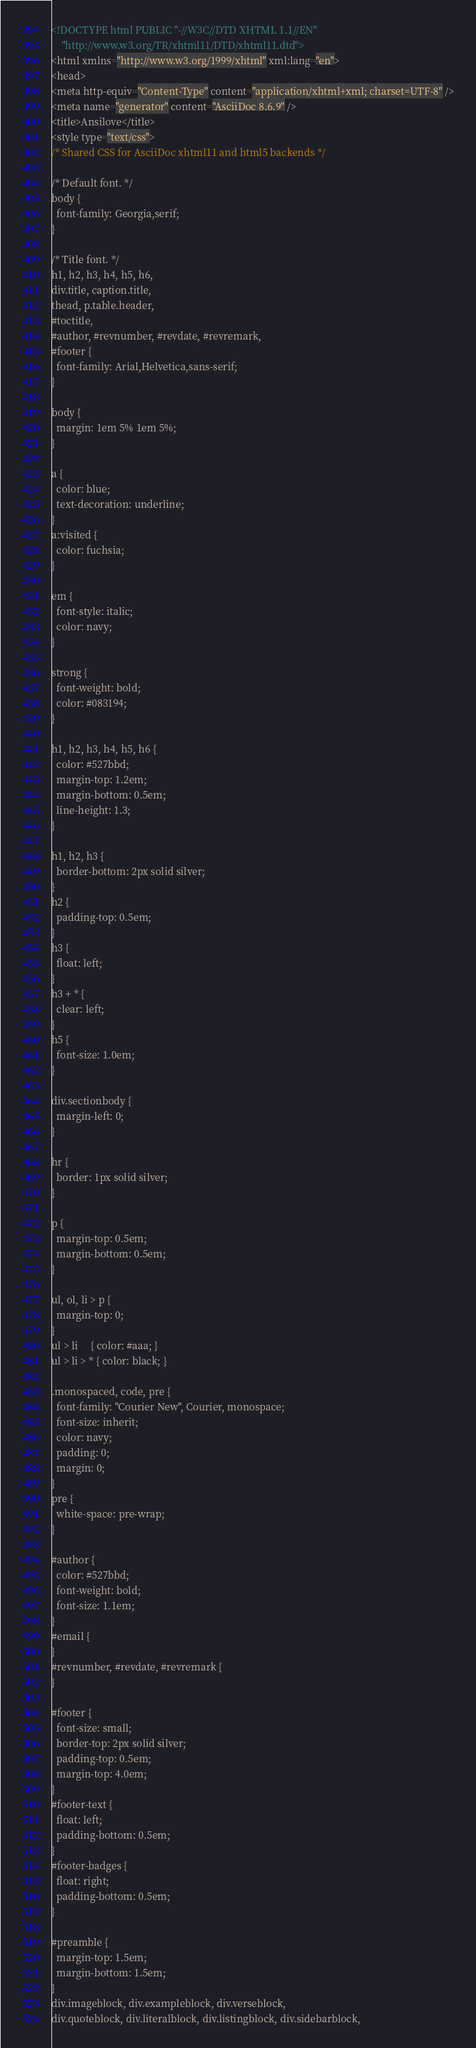<code> <loc_0><loc_0><loc_500><loc_500><_HTML_><!DOCTYPE html PUBLIC "-//W3C//DTD XHTML 1.1//EN"
    "http://www.w3.org/TR/xhtml11/DTD/xhtml11.dtd">
<html xmlns="http://www.w3.org/1999/xhtml" xml:lang="en">
<head>
<meta http-equiv="Content-Type" content="application/xhtml+xml; charset=UTF-8" />
<meta name="generator" content="AsciiDoc 8.6.9" />
<title>Ansilove</title>
<style type="text/css">
/* Shared CSS for AsciiDoc xhtml11 and html5 backends */

/* Default font. */
body {
  font-family: Georgia,serif;
}

/* Title font. */
h1, h2, h3, h4, h5, h6,
div.title, caption.title,
thead, p.table.header,
#toctitle,
#author, #revnumber, #revdate, #revremark,
#footer {
  font-family: Arial,Helvetica,sans-serif;
}

body {
  margin: 1em 5% 1em 5%;
}

a {
  color: blue;
  text-decoration: underline;
}
a:visited {
  color: fuchsia;
}

em {
  font-style: italic;
  color: navy;
}

strong {
  font-weight: bold;
  color: #083194;
}

h1, h2, h3, h4, h5, h6 {
  color: #527bbd;
  margin-top: 1.2em;
  margin-bottom: 0.5em;
  line-height: 1.3;
}

h1, h2, h3 {
  border-bottom: 2px solid silver;
}
h2 {
  padding-top: 0.5em;
}
h3 {
  float: left;
}
h3 + * {
  clear: left;
}
h5 {
  font-size: 1.0em;
}

div.sectionbody {
  margin-left: 0;
}

hr {
  border: 1px solid silver;
}

p {
  margin-top: 0.5em;
  margin-bottom: 0.5em;
}

ul, ol, li > p {
  margin-top: 0;
}
ul > li     { color: #aaa; }
ul > li > * { color: black; }

.monospaced, code, pre {
  font-family: "Courier New", Courier, monospace;
  font-size: inherit;
  color: navy;
  padding: 0;
  margin: 0;
}
pre {
  white-space: pre-wrap;
}

#author {
  color: #527bbd;
  font-weight: bold;
  font-size: 1.1em;
}
#email {
}
#revnumber, #revdate, #revremark {
}

#footer {
  font-size: small;
  border-top: 2px solid silver;
  padding-top: 0.5em;
  margin-top: 4.0em;
}
#footer-text {
  float: left;
  padding-bottom: 0.5em;
}
#footer-badges {
  float: right;
  padding-bottom: 0.5em;
}

#preamble {
  margin-top: 1.5em;
  margin-bottom: 1.5em;
}
div.imageblock, div.exampleblock, div.verseblock,
div.quoteblock, div.literalblock, div.listingblock, div.sidebarblock,</code> 